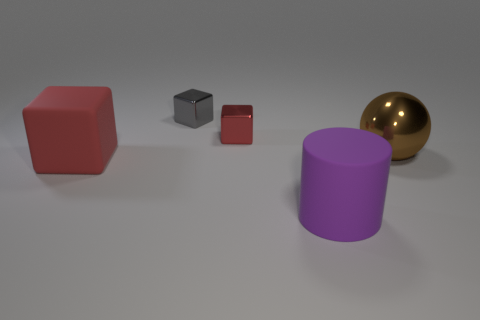Subtract all metal blocks. How many blocks are left? 1 Subtract all cyan cylinders. How many red blocks are left? 2 Subtract 1 blocks. How many blocks are left? 2 Add 1 small red shiny blocks. How many objects exist? 6 Subtract all cylinders. How many objects are left? 4 Subtract all gray cubes. Subtract all large purple rubber things. How many objects are left? 3 Add 2 big purple matte cylinders. How many big purple matte cylinders are left? 3 Add 5 tiny purple metallic spheres. How many tiny purple metallic spheres exist? 5 Subtract 1 purple cylinders. How many objects are left? 4 Subtract all brown blocks. Subtract all blue balls. How many blocks are left? 3 